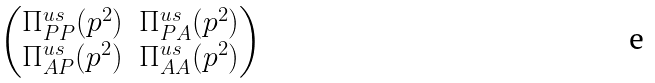Convert formula to latex. <formula><loc_0><loc_0><loc_500><loc_500>\begin{pmatrix} \Pi ^ { u s } _ { P P } ( p ^ { 2 } ) & \Pi ^ { u s } _ { P A } ( p ^ { 2 } ) \\ \Pi ^ { u s } _ { A P } ( p ^ { 2 } ) & \Pi ^ { u s } _ { A A } ( p ^ { 2 } ) \end{pmatrix}</formula> 